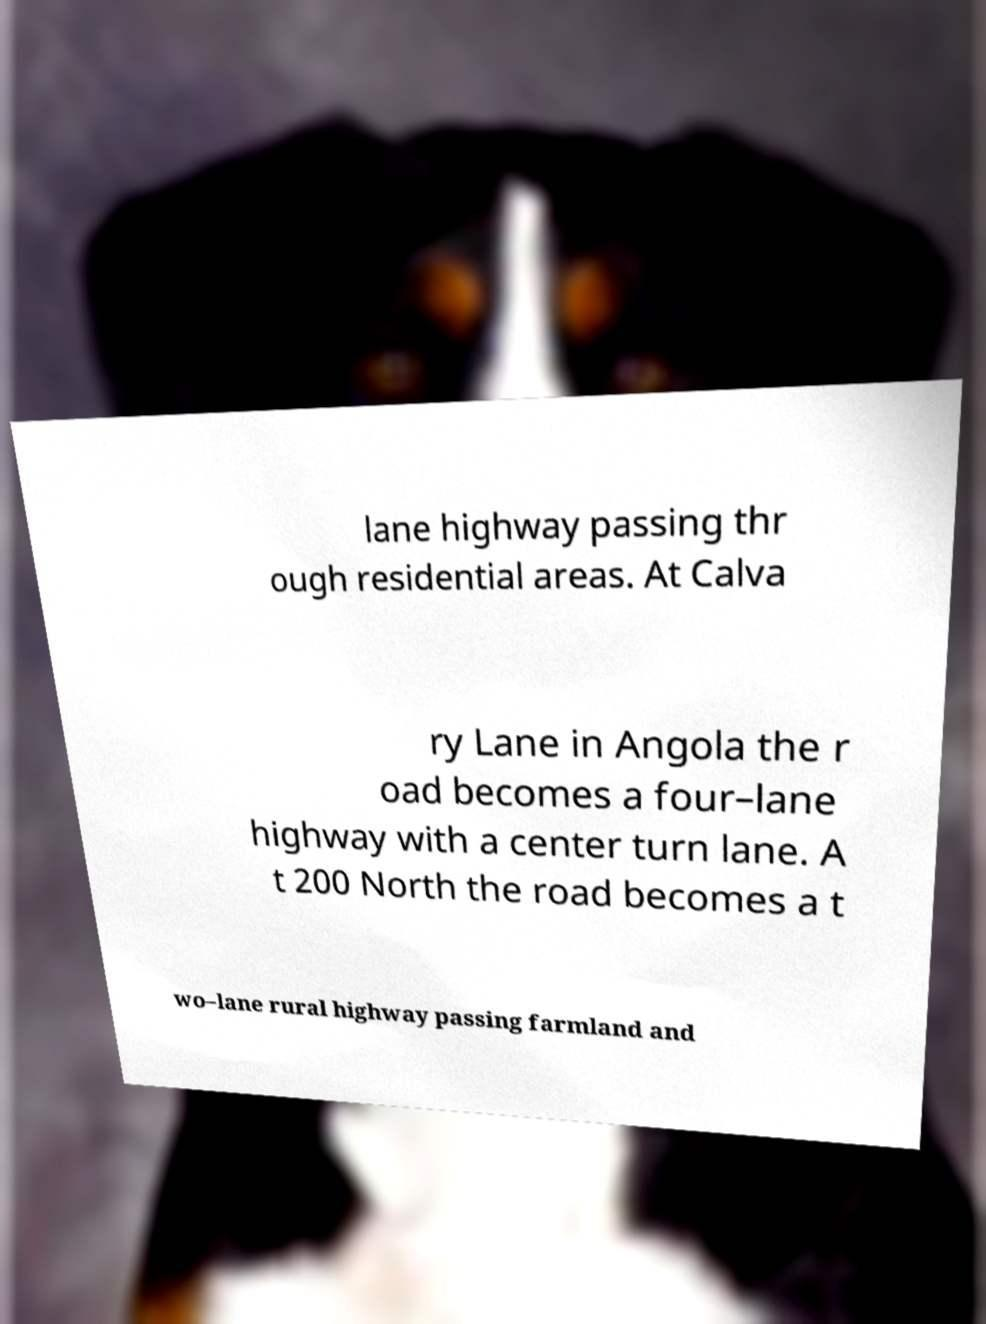Please read and relay the text visible in this image. What does it say? lane highway passing thr ough residential areas. At Calva ry Lane in Angola the r oad becomes a four–lane highway with a center turn lane. A t 200 North the road becomes a t wo–lane rural highway passing farmland and 